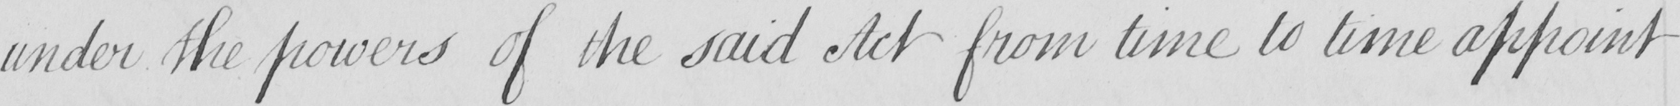What does this handwritten line say? under the powers of the said Act from time to time appoint 